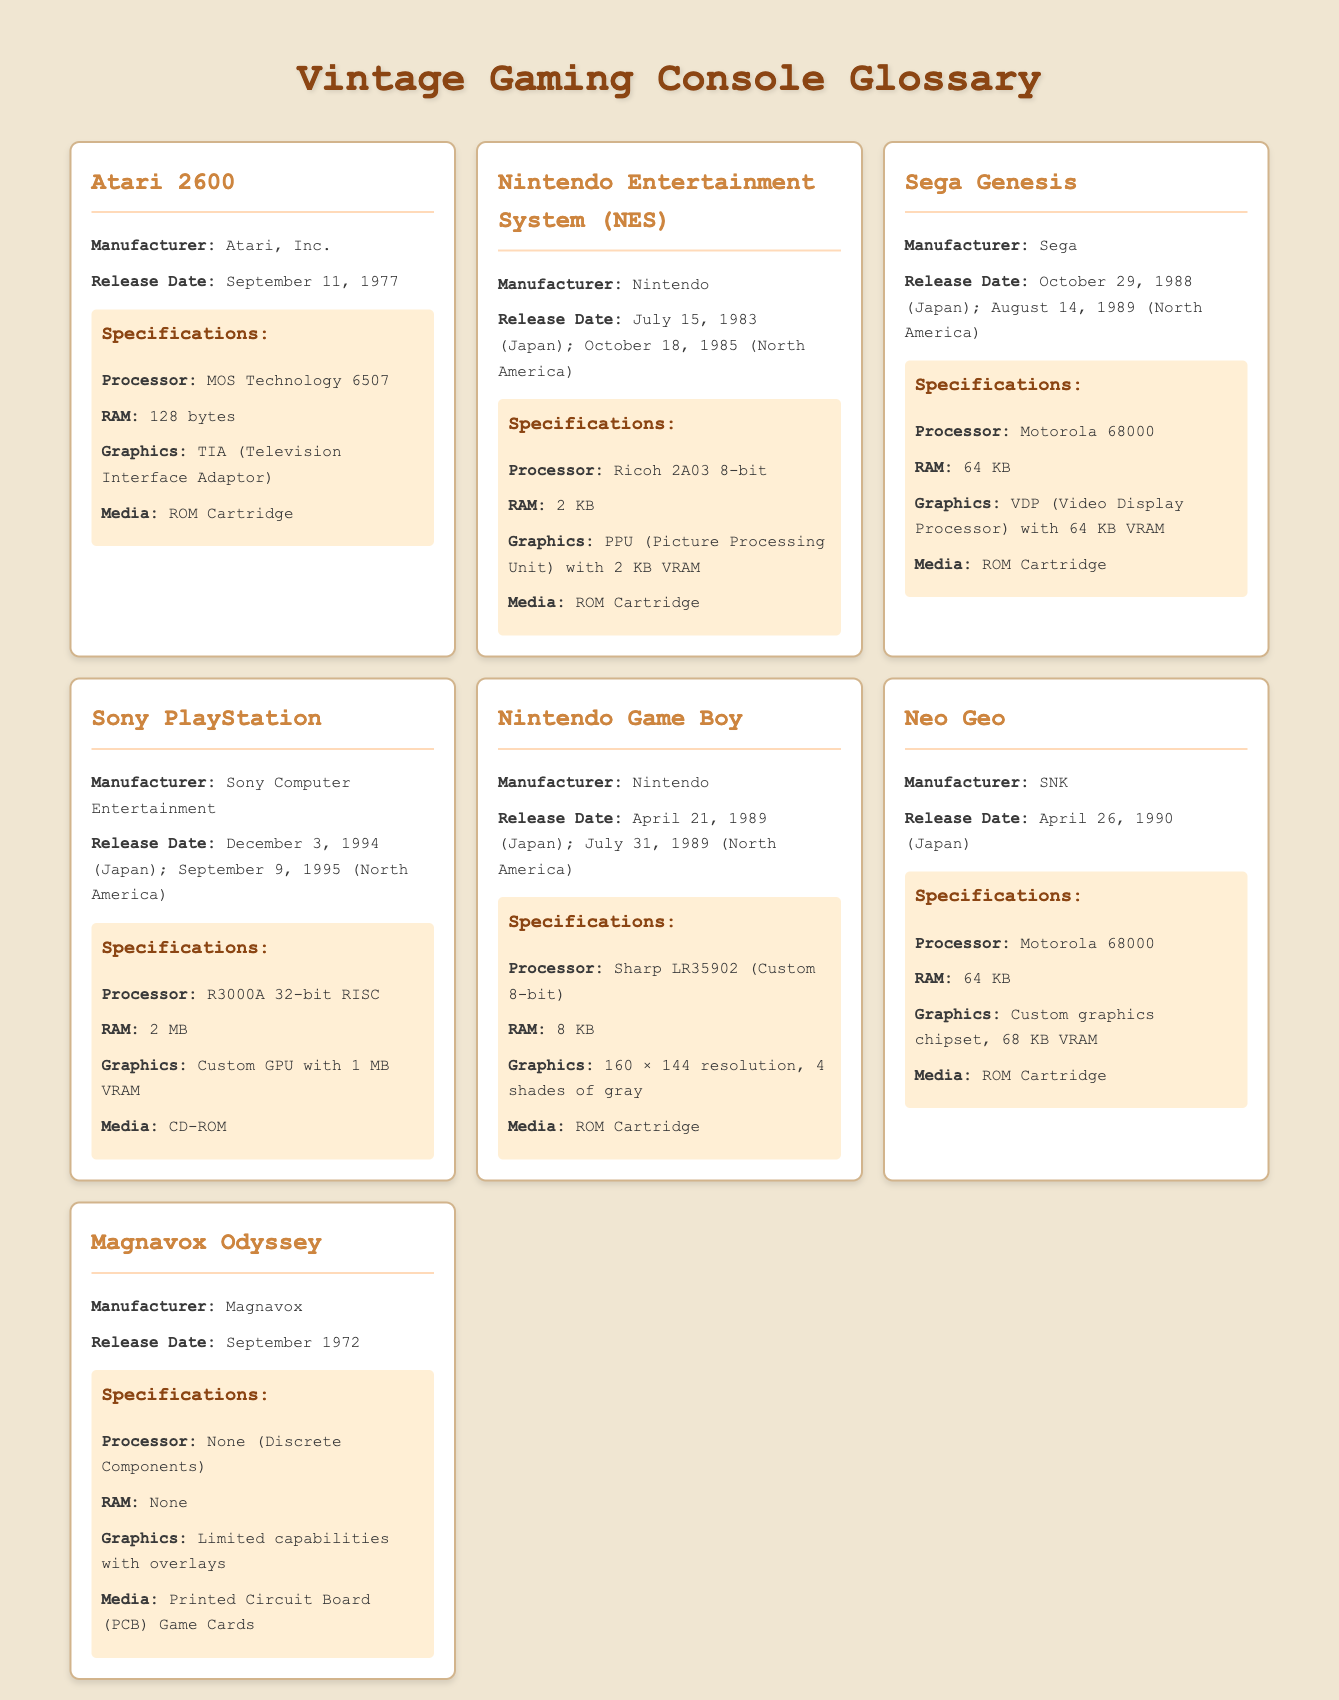What is the release date of the Atari 2600? The release date of the Atari 2600 is mentioned directly under its entry in the document.
Answer: September 11, 1977 Who manufactured the NES? The manufacturer of the NES is stated in the document, providing clear identification of its creator.
Answer: Nintendo What is the RAM of the Sega Genesis? The RAM information for the Sega Genesis is included in the specifications section and indicates its memory capacity.
Answer: 64 KB What type of media does the Sony PlayStation use? The media type utilized by the Sony PlayStation is specified under its specifications, giving insights into how games are loaded.
Answer: CD-ROM Which console was released first, the Magnavox Odyssey or the Neo Geo? To determine which console was released first, we compare the release dates provided in each console's entry within the document.
Answer: Magnavox Odyssey How much RAM does the Nintendo Game Boy have? The document specifies the RAM for the Nintendo Game Boy in its specifications, indicating its memory capacity.
Answer: 8 KB What is the graphics processor in the NES? The document includes the graphics processor information specifically for the NES within its specifications section.
Answer: PPU (Picture Processing Unit) with 2 KB VRAM Which console has no RAM? The specifications listed for the Magnavox Odyssey indicate its lack of RAM when assessed.
Answer: None When was the Sega Genesis released in North America? The North American release date of the Sega Genesis is clearly stated within its entry.
Answer: August 14, 1989 